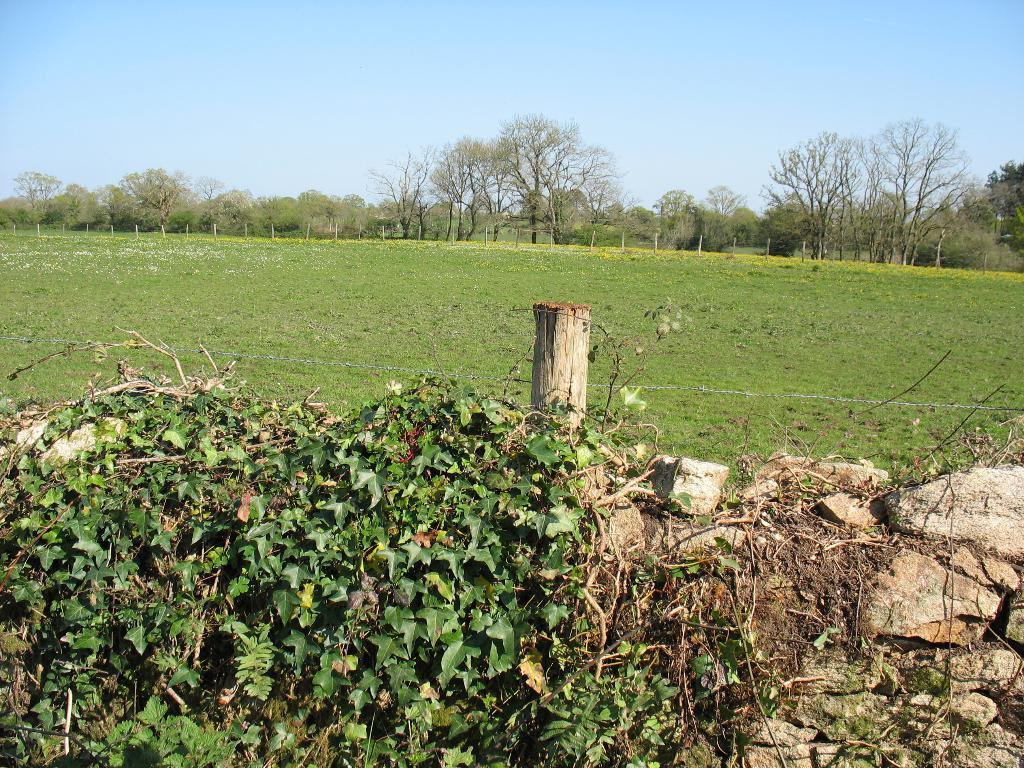What type of natural elements can be seen on the right side of the image? There are stones on the right side of the image. What type of vegetation is visible in the background of the image? There is grass visible in the background of the image. What other natural elements can be seen in the background of the image? There are trees in the background of the image. What is visible above the trees and grass in the image? The sky is visible in the background of the image. How many flowers are present on the stones in the image? There are no flowers mentioned or visible in the image; it only features stones, grass, trees, and the sky. 